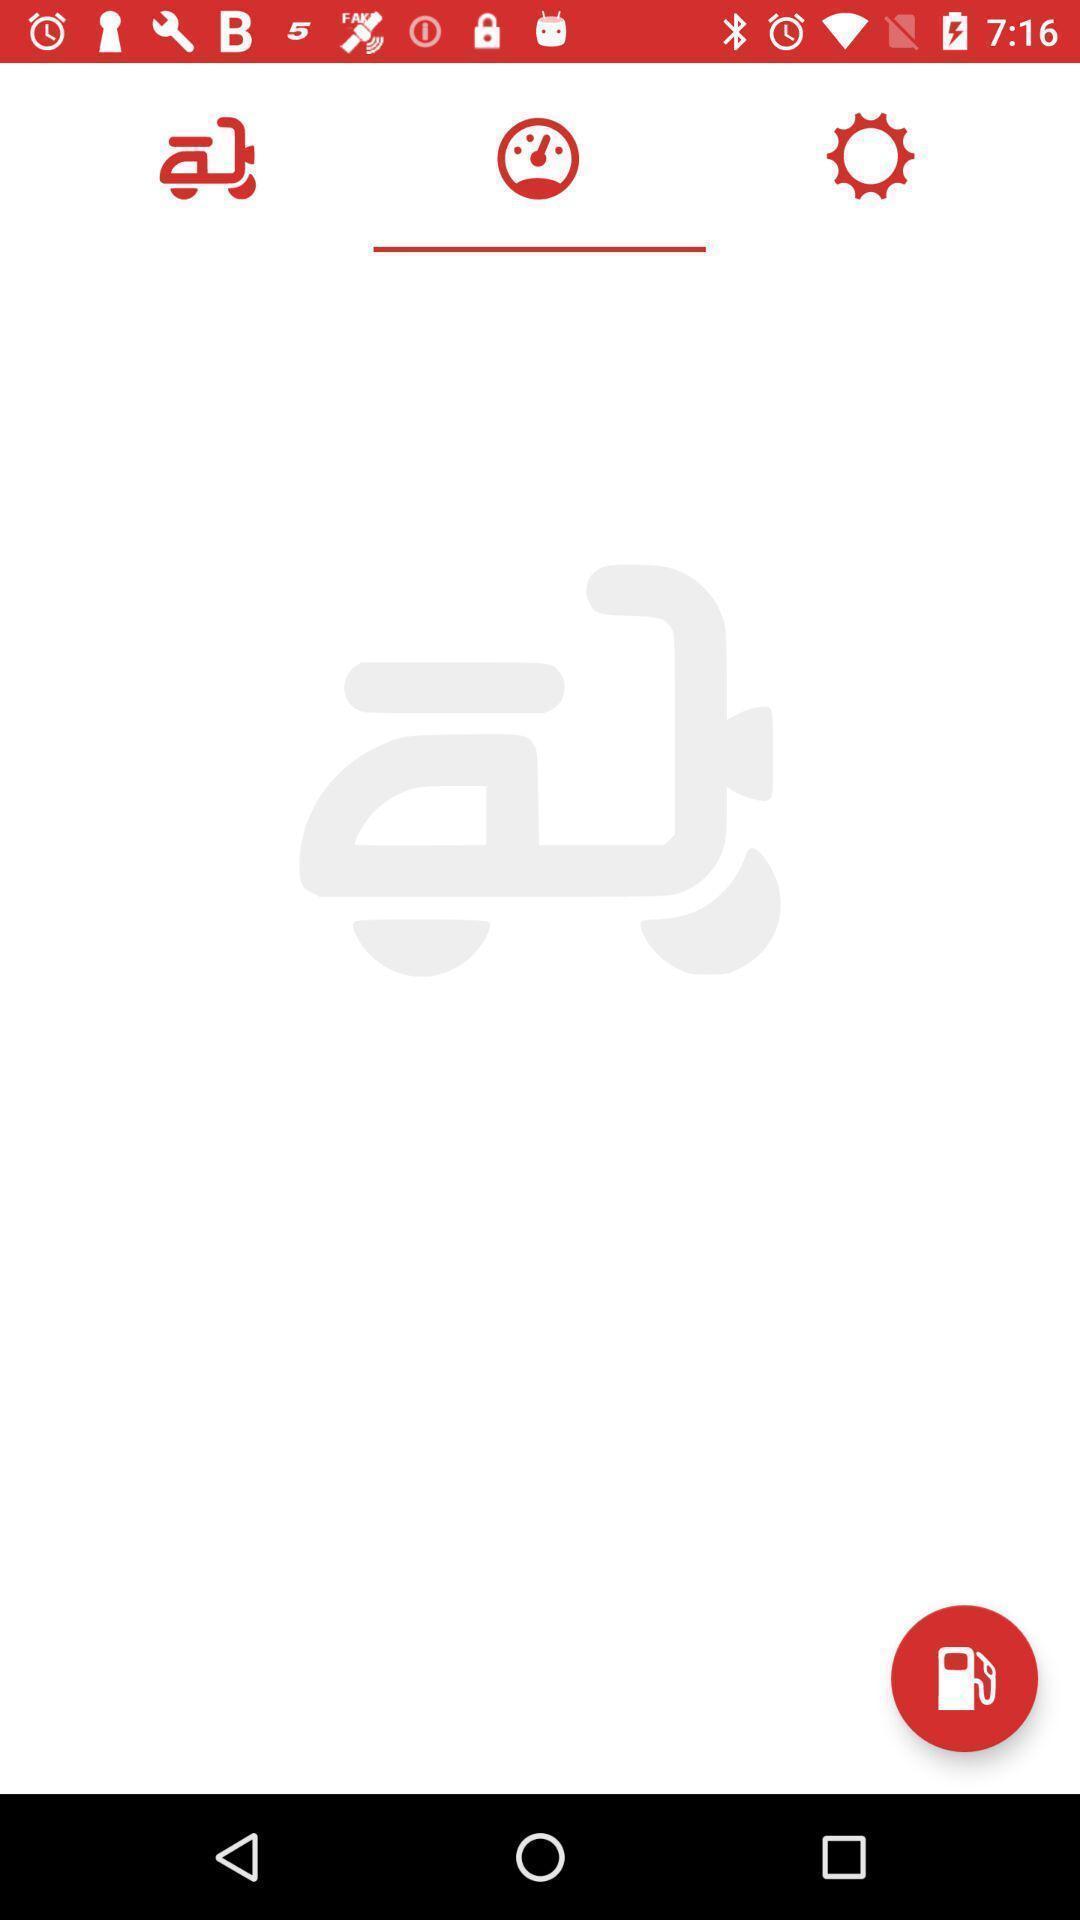Provide a textual representation of this image. Tools in motor cycle fuel tracker. 